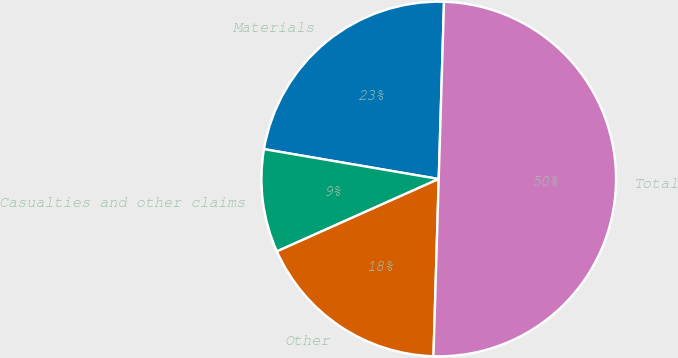<chart> <loc_0><loc_0><loc_500><loc_500><pie_chart><fcel>Materials<fcel>Casualties and other claims<fcel>Other<fcel>Total<nl><fcel>22.78%<fcel>9.39%<fcel>17.83%<fcel>50.0%<nl></chart> 